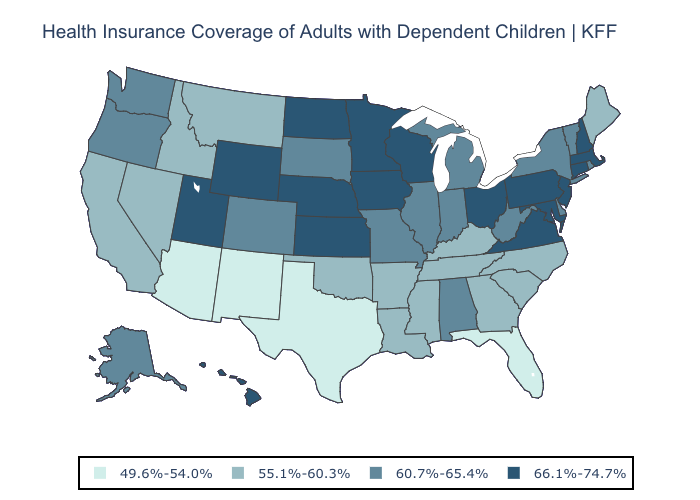Among the states that border Pennsylvania , does Delaware have the highest value?
Keep it brief. No. Does the map have missing data?
Write a very short answer. No. What is the highest value in states that border Colorado?
Short answer required. 66.1%-74.7%. Does the first symbol in the legend represent the smallest category?
Give a very brief answer. Yes. What is the lowest value in the USA?
Give a very brief answer. 49.6%-54.0%. Does Arkansas have a lower value than Montana?
Short answer required. No. Name the states that have a value in the range 55.1%-60.3%?
Give a very brief answer. Arkansas, California, Georgia, Idaho, Kentucky, Louisiana, Maine, Mississippi, Montana, Nevada, North Carolina, Oklahoma, South Carolina, Tennessee. What is the value of Nevada?
Short answer required. 55.1%-60.3%. What is the lowest value in states that border Kentucky?
Concise answer only. 55.1%-60.3%. Does the first symbol in the legend represent the smallest category?
Concise answer only. Yes. Name the states that have a value in the range 66.1%-74.7%?
Answer briefly. Connecticut, Hawaii, Iowa, Kansas, Maryland, Massachusetts, Minnesota, Nebraska, New Hampshire, New Jersey, North Dakota, Ohio, Pennsylvania, Utah, Virginia, Wisconsin, Wyoming. What is the highest value in the USA?
Short answer required. 66.1%-74.7%. Which states have the highest value in the USA?
Quick response, please. Connecticut, Hawaii, Iowa, Kansas, Maryland, Massachusetts, Minnesota, Nebraska, New Hampshire, New Jersey, North Dakota, Ohio, Pennsylvania, Utah, Virginia, Wisconsin, Wyoming. What is the highest value in the South ?
Be succinct. 66.1%-74.7%. Does Florida have the lowest value in the USA?
Be succinct. Yes. 